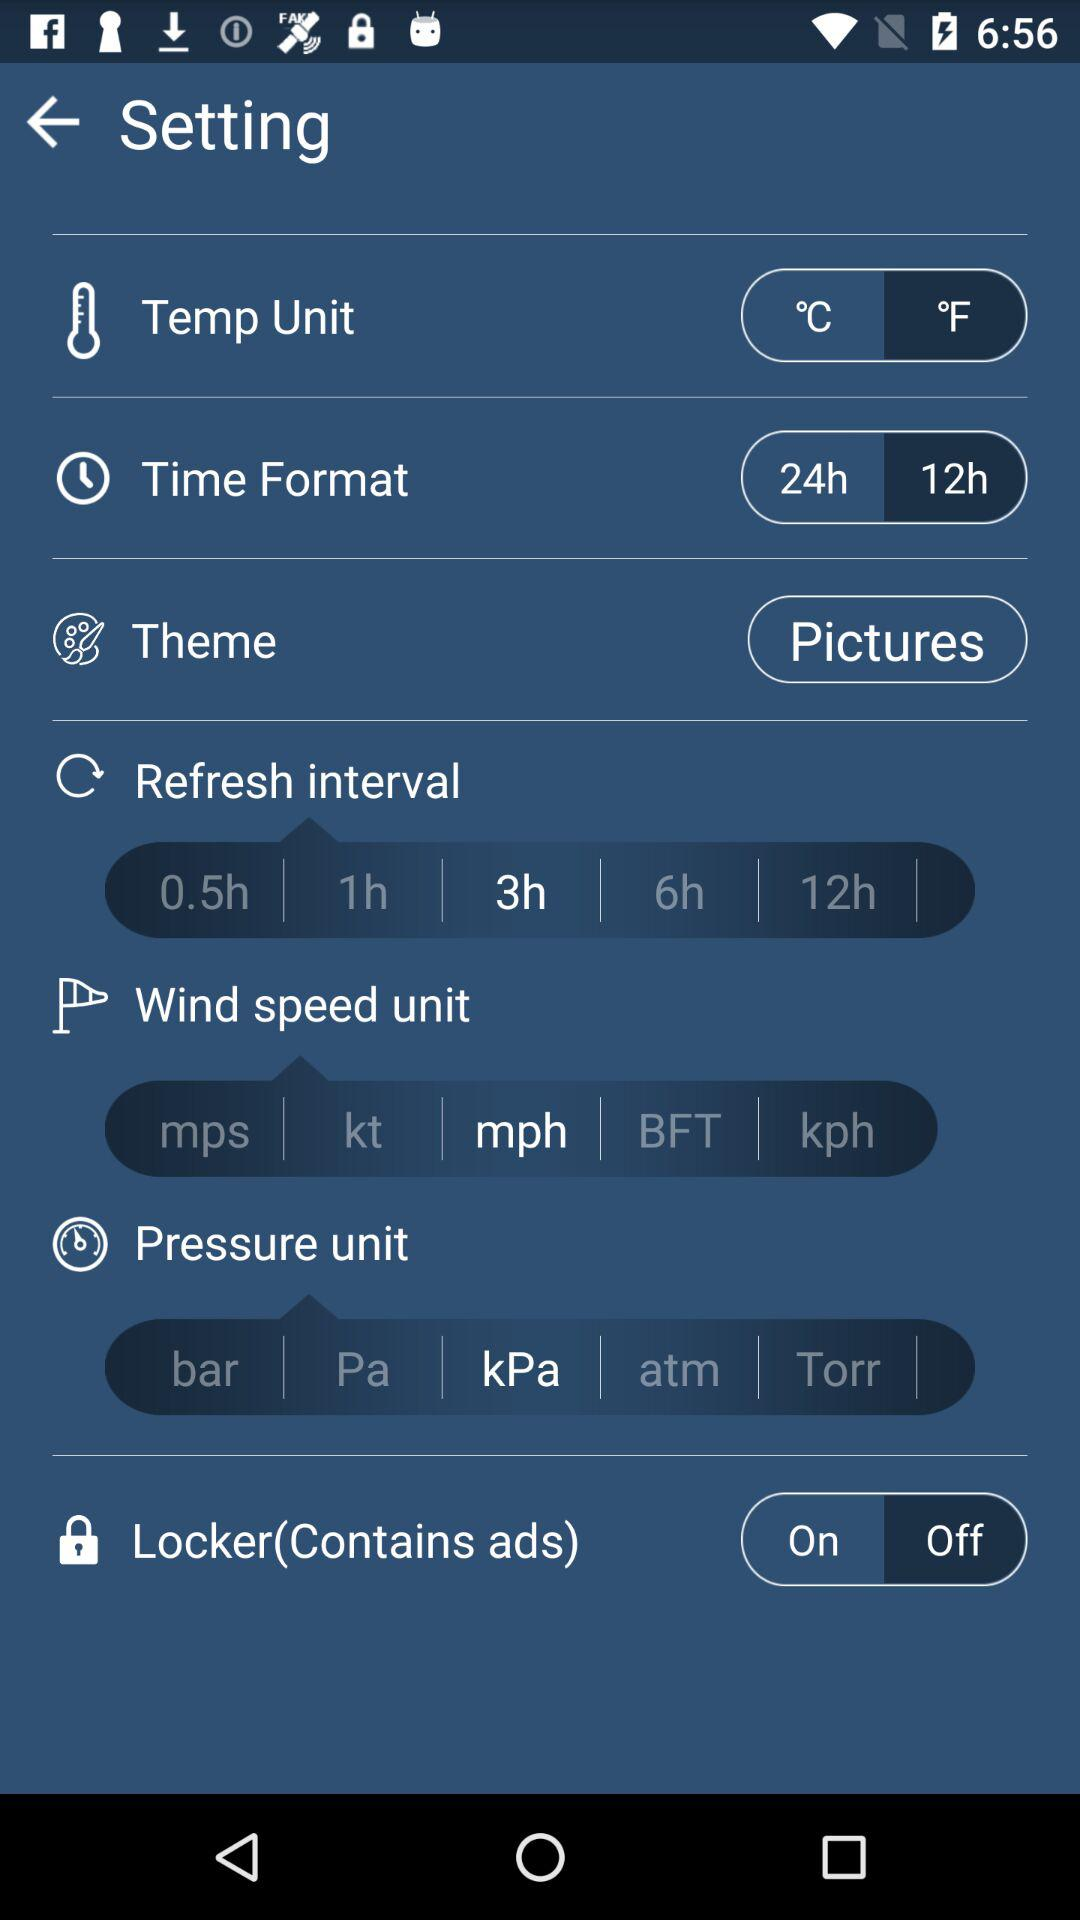Which temp unit has been selected? The temp unit that has been selected is °F. 